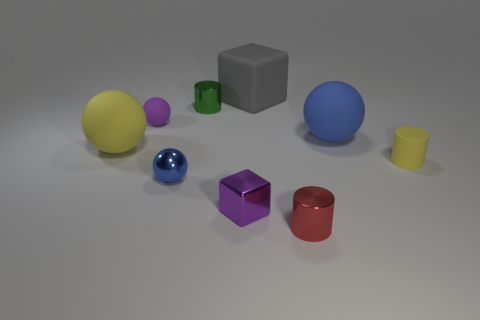Do the big rubber ball left of the large blue object and the matte cylinder have the same color?
Your response must be concise. Yes. There is a shiny thing that is the same color as the small rubber ball; what is its shape?
Offer a terse response. Cube. What number of blue things have the same material as the small green thing?
Give a very brief answer. 1. What number of tiny shiny cylinders are in front of the tiny yellow thing?
Make the answer very short. 1. What is the size of the yellow rubber ball?
Make the answer very short. Large. There is another matte ball that is the same size as the yellow rubber ball; what is its color?
Give a very brief answer. Blue. Are there any small spheres that have the same color as the small block?
Provide a short and direct response. Yes. What is the small purple cube made of?
Provide a succinct answer. Metal. What number of large red matte cylinders are there?
Offer a terse response. 0. Do the block in front of the green cylinder and the tiny rubber object to the left of the metal ball have the same color?
Offer a very short reply. Yes. 